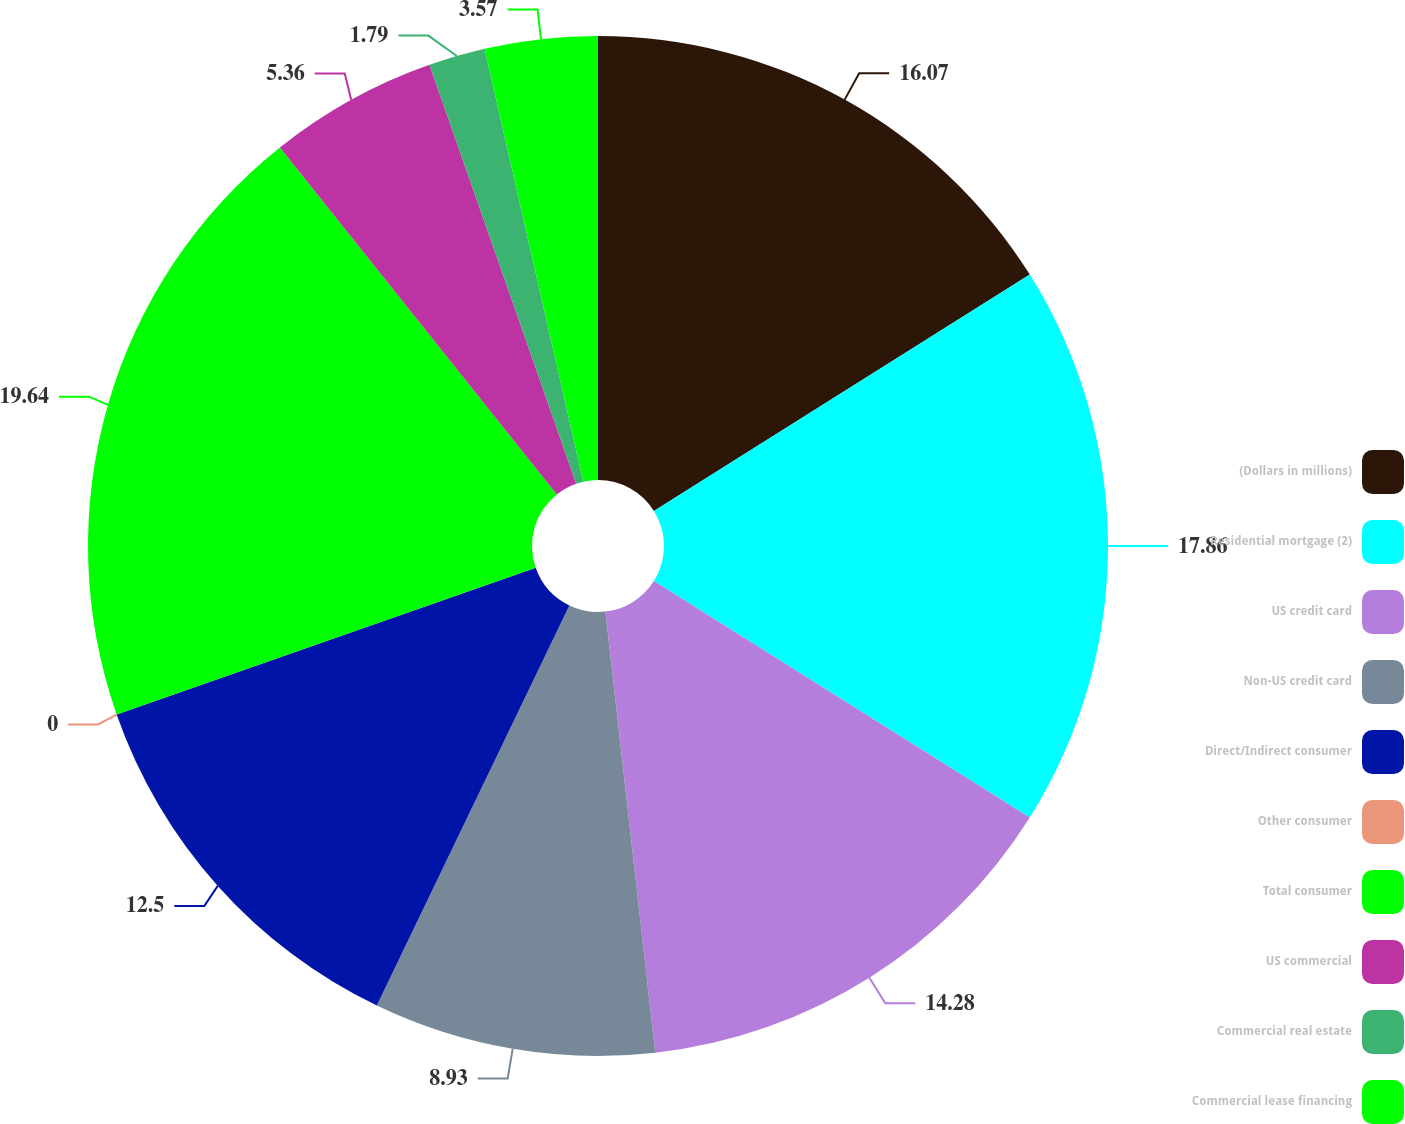Convert chart to OTSL. <chart><loc_0><loc_0><loc_500><loc_500><pie_chart><fcel>(Dollars in millions)<fcel>Residential mortgage (2)<fcel>US credit card<fcel>Non-US credit card<fcel>Direct/Indirect consumer<fcel>Other consumer<fcel>Total consumer<fcel>US commercial<fcel>Commercial real estate<fcel>Commercial lease financing<nl><fcel>16.07%<fcel>17.86%<fcel>14.28%<fcel>8.93%<fcel>12.5%<fcel>0.0%<fcel>19.64%<fcel>5.36%<fcel>1.79%<fcel>3.57%<nl></chart> 